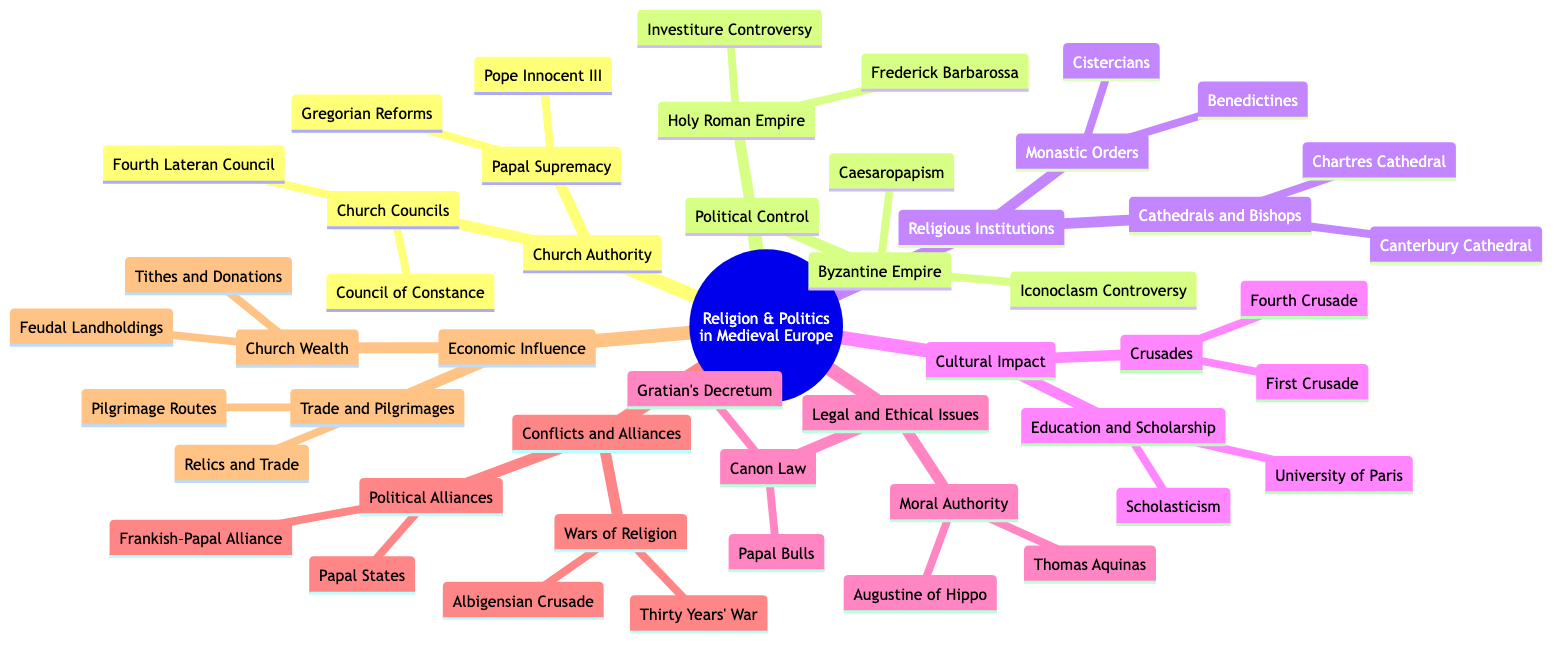What are the two main topics under Church Authority? The diagram lists two categories under Church Authority: Papal Supremacy and Church Councils. These are the main divisions representing the influence of the Church in medieval politics.
Answer: Papal Supremacy, Church Councils How many religious institutions are mentioned in the diagram? The diagram identifies two categories under Religious Institutions: Monastic Orders and Cathedrals and Bishops. Each category contains two specific examples, totaling four distinct religious institutions.
Answer: 4 What event is related to the Investiture Controversy in the Holy Roman Empire? The diagram connects the Investiture Controversy directly with Frederick Barbarossa, indicating a significant conflict over authority that involved this emperor.
Answer: Frederick Barbarossa Which Crusade is listed as the first in the Cultural Impact section? The diagram lists the First Crusade as the initial event under the Crusades category in the Cultural Impact section, establishing its importance in the religious and political landscape of the era.
Answer: First Crusade What document represents Canon Law in the Legal and Ethical Issues section? The diagram specifically mentions Gratian's Decretum as a key document representing Canon Law, signifying its role in establishing legal practices within the Church.
Answer: Gratian's Decretum Which philosophical figure is associated with the concept of Moral Authority? The diagram highlights both Thomas Aquinas and Augustine of Hippo under Moral Authority, suggesting their contributions to ethical and moral philosophy within a religious context.
Answer: Thomas Aquinas, Augustine of Hippo What does the Economic Influence section say about Church Wealth? The diagram stated that Church Wealth is associated with Tithes and Donations as well as Feudal Landholdings, showing how the Church accumulated resources and power through economic means.
Answer: Tithes and Donations, Feudal Landholdings In which empire can Caesaropapism be found according to the diagram? The diagram categorizes Caesaropapism under the Byzantine Empire, indicating its specific political-religious structure that intertwines imperial and ecclesiastical authority.
Answer: Byzantine Empire What major conflict is mentioned alongside the Albigensian Crusade? The diagram associates the Albigensian Crusade with the Thirty Years' War, both of which are categorized under Wars of Religion, illustrating how religion and politics often fueled extended conflicts.
Answer: Thirty Years' War 